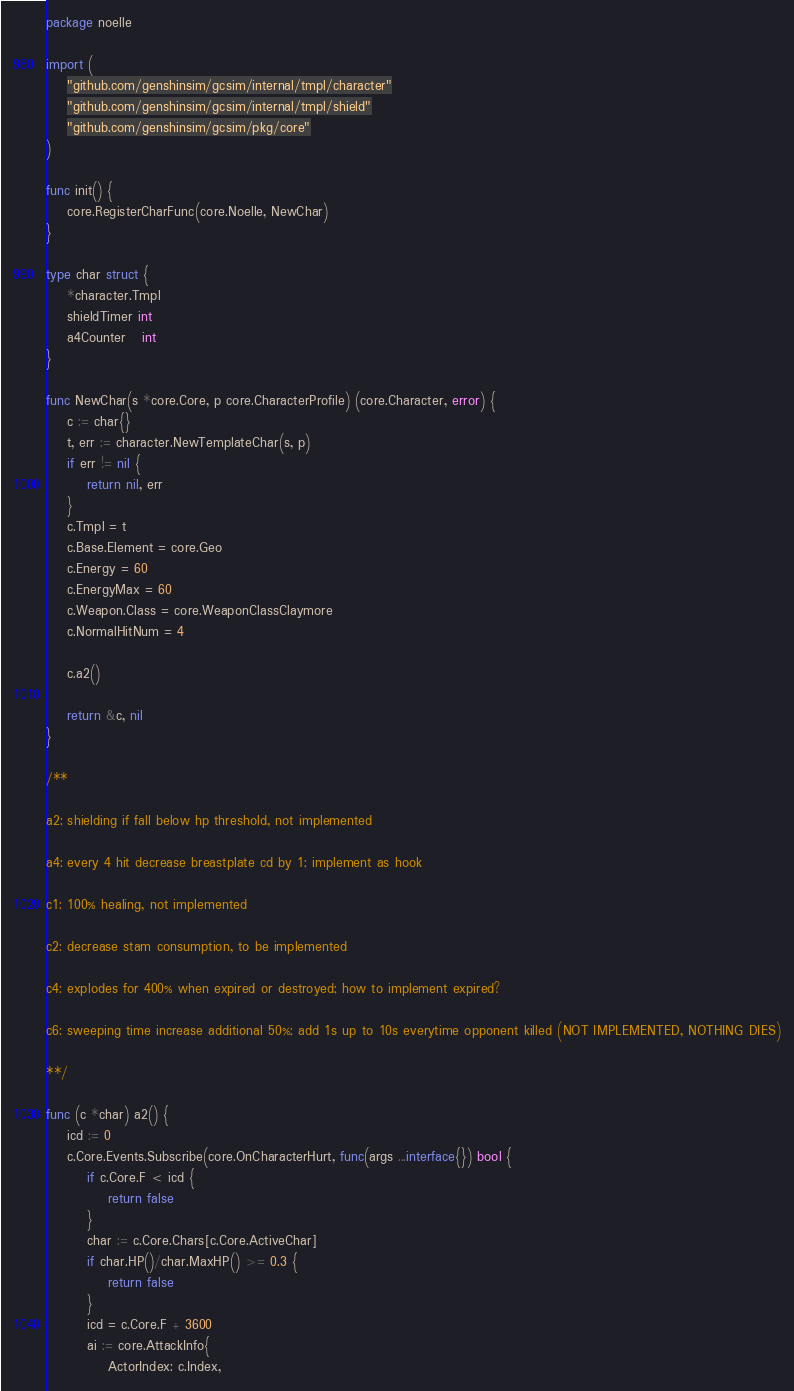Convert code to text. <code><loc_0><loc_0><loc_500><loc_500><_Go_>package noelle

import (
	"github.com/genshinsim/gcsim/internal/tmpl/character"
	"github.com/genshinsim/gcsim/internal/tmpl/shield"
	"github.com/genshinsim/gcsim/pkg/core"
)

func init() {
	core.RegisterCharFunc(core.Noelle, NewChar)
}

type char struct {
	*character.Tmpl
	shieldTimer int
	a4Counter   int
}

func NewChar(s *core.Core, p core.CharacterProfile) (core.Character, error) {
	c := char{}
	t, err := character.NewTemplateChar(s, p)
	if err != nil {
		return nil, err
	}
	c.Tmpl = t
	c.Base.Element = core.Geo
	c.Energy = 60
	c.EnergyMax = 60
	c.Weapon.Class = core.WeaponClassClaymore
	c.NormalHitNum = 4

	c.a2()

	return &c, nil
}

/**

a2: shielding if fall below hp threshold, not implemented

a4: every 4 hit decrease breastplate cd by 1; implement as hook

c1: 100% healing, not implemented

c2: decrease stam consumption, to be implemented

c4: explodes for 400% when expired or destroyed; how to implement expired?

c6: sweeping time increase additional 50%; add 1s up to 10s everytime opponent killed (NOT IMPLEMENTED, NOTHING DIES)

**/

func (c *char) a2() {
	icd := 0
	c.Core.Events.Subscribe(core.OnCharacterHurt, func(args ...interface{}) bool {
		if c.Core.F < icd {
			return false
		}
		char := c.Core.Chars[c.Core.ActiveChar]
		if char.HP()/char.MaxHP() >= 0.3 {
			return false
		}
		icd = c.Core.F + 3600
		ai := core.AttackInfo{
			ActorIndex: c.Index,</code> 